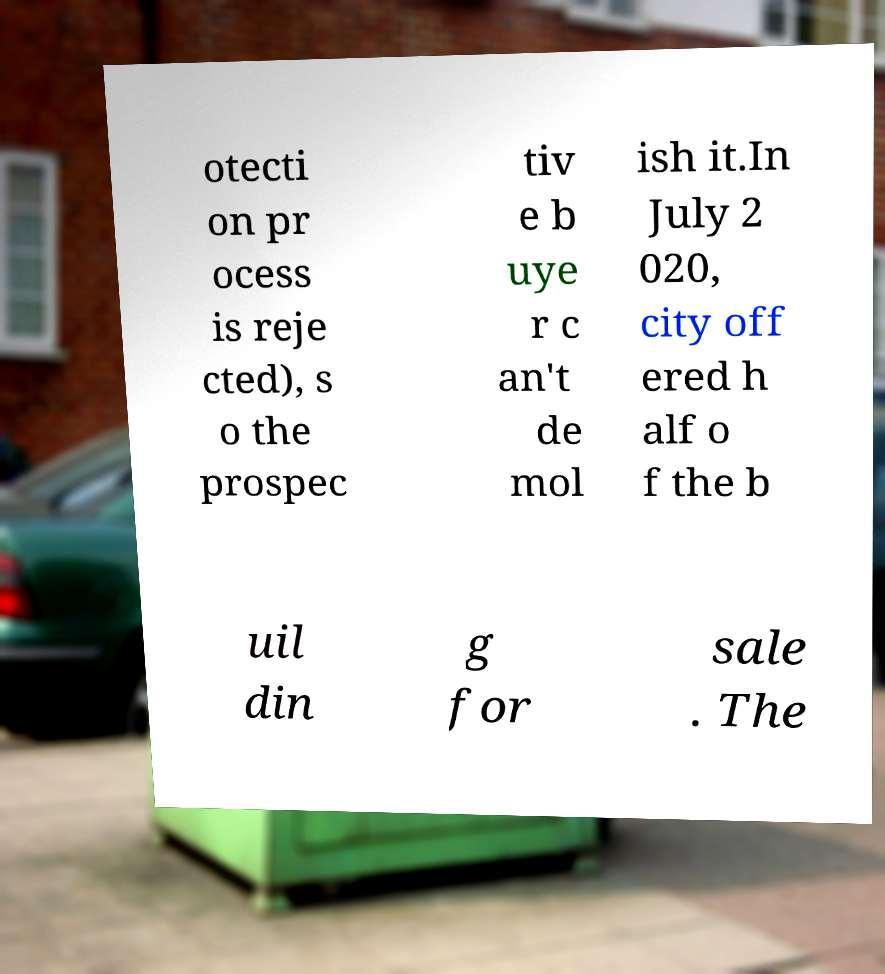Could you assist in decoding the text presented in this image and type it out clearly? otecti on pr ocess is reje cted), s o the prospec tiv e b uye r c an't de mol ish it.In July 2 020, city off ered h alf o f the b uil din g for sale . The 